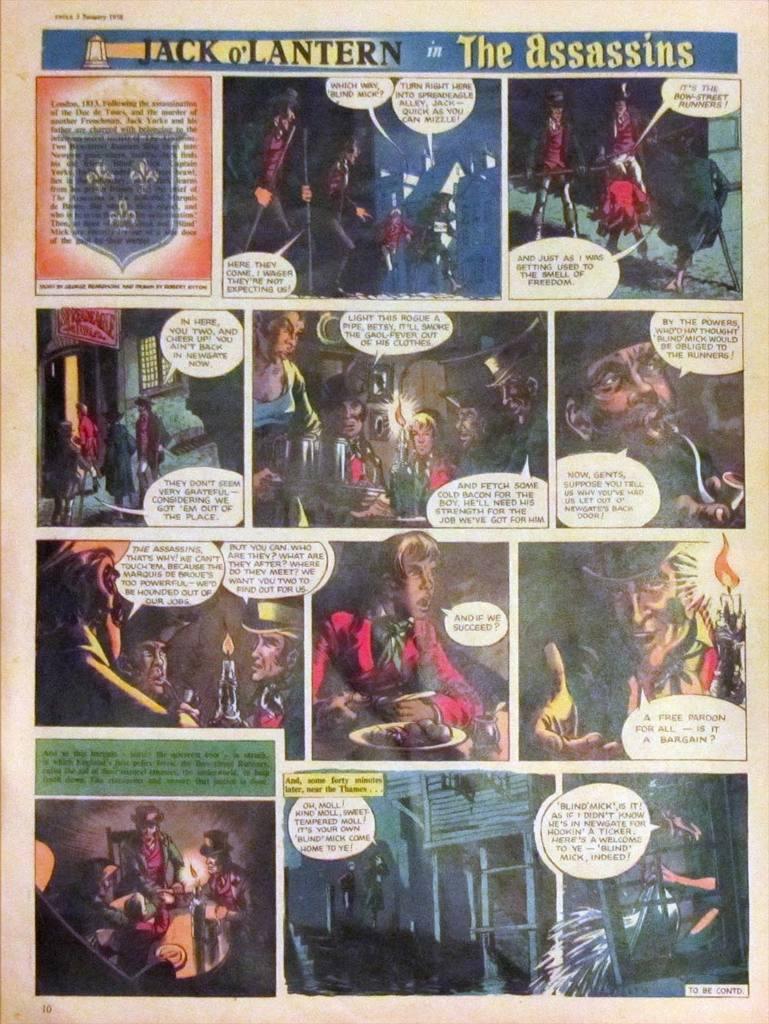What was he getting used to in the top right box?
Your answer should be compact. The smell of freedom. 